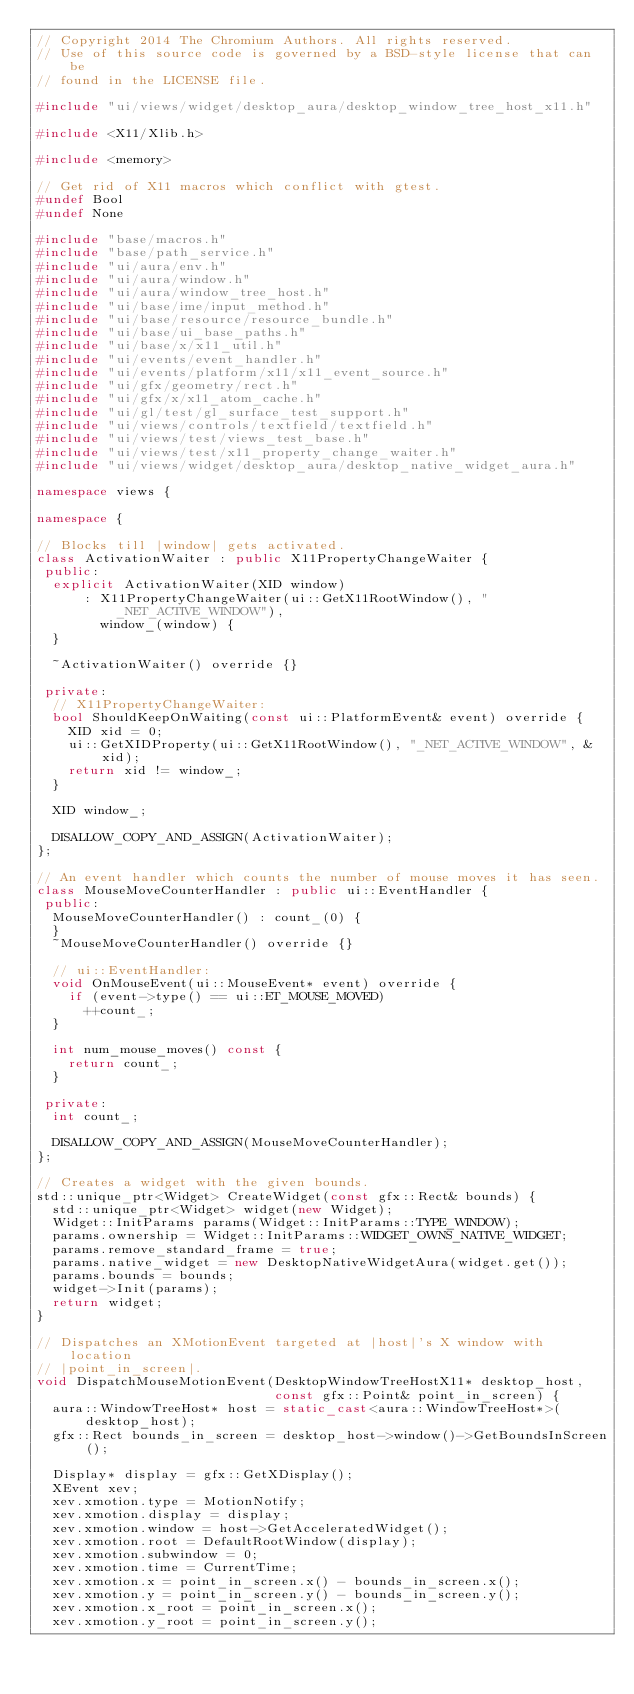Convert code to text. <code><loc_0><loc_0><loc_500><loc_500><_C++_>// Copyright 2014 The Chromium Authors. All rights reserved.
// Use of this source code is governed by a BSD-style license that can be
// found in the LICENSE file.

#include "ui/views/widget/desktop_aura/desktop_window_tree_host_x11.h"

#include <X11/Xlib.h>

#include <memory>

// Get rid of X11 macros which conflict with gtest.
#undef Bool
#undef None

#include "base/macros.h"
#include "base/path_service.h"
#include "ui/aura/env.h"
#include "ui/aura/window.h"
#include "ui/aura/window_tree_host.h"
#include "ui/base/ime/input_method.h"
#include "ui/base/resource/resource_bundle.h"
#include "ui/base/ui_base_paths.h"
#include "ui/base/x/x11_util.h"
#include "ui/events/event_handler.h"
#include "ui/events/platform/x11/x11_event_source.h"
#include "ui/gfx/geometry/rect.h"
#include "ui/gfx/x/x11_atom_cache.h"
#include "ui/gl/test/gl_surface_test_support.h"
#include "ui/views/controls/textfield/textfield.h"
#include "ui/views/test/views_test_base.h"
#include "ui/views/test/x11_property_change_waiter.h"
#include "ui/views/widget/desktop_aura/desktop_native_widget_aura.h"

namespace views {

namespace {

// Blocks till |window| gets activated.
class ActivationWaiter : public X11PropertyChangeWaiter {
 public:
  explicit ActivationWaiter(XID window)
      : X11PropertyChangeWaiter(ui::GetX11RootWindow(), "_NET_ACTIVE_WINDOW"),
        window_(window) {
  }

  ~ActivationWaiter() override {}

 private:
  // X11PropertyChangeWaiter:
  bool ShouldKeepOnWaiting(const ui::PlatformEvent& event) override {
    XID xid = 0;
    ui::GetXIDProperty(ui::GetX11RootWindow(), "_NET_ACTIVE_WINDOW", &xid);
    return xid != window_;
  }

  XID window_;

  DISALLOW_COPY_AND_ASSIGN(ActivationWaiter);
};

// An event handler which counts the number of mouse moves it has seen.
class MouseMoveCounterHandler : public ui::EventHandler {
 public:
  MouseMoveCounterHandler() : count_(0) {
  }
  ~MouseMoveCounterHandler() override {}

  // ui::EventHandler:
  void OnMouseEvent(ui::MouseEvent* event) override {
    if (event->type() == ui::ET_MOUSE_MOVED)
      ++count_;
  }

  int num_mouse_moves() const {
    return count_;
  }

 private:
  int count_;

  DISALLOW_COPY_AND_ASSIGN(MouseMoveCounterHandler);
};

// Creates a widget with the given bounds.
std::unique_ptr<Widget> CreateWidget(const gfx::Rect& bounds) {
  std::unique_ptr<Widget> widget(new Widget);
  Widget::InitParams params(Widget::InitParams::TYPE_WINDOW);
  params.ownership = Widget::InitParams::WIDGET_OWNS_NATIVE_WIDGET;
  params.remove_standard_frame = true;
  params.native_widget = new DesktopNativeWidgetAura(widget.get());
  params.bounds = bounds;
  widget->Init(params);
  return widget;
}

// Dispatches an XMotionEvent targeted at |host|'s X window with location
// |point_in_screen|.
void DispatchMouseMotionEvent(DesktopWindowTreeHostX11* desktop_host,
                              const gfx::Point& point_in_screen) {
  aura::WindowTreeHost* host = static_cast<aura::WindowTreeHost*>(desktop_host);
  gfx::Rect bounds_in_screen = desktop_host->window()->GetBoundsInScreen();

  Display* display = gfx::GetXDisplay();
  XEvent xev;
  xev.xmotion.type = MotionNotify;
  xev.xmotion.display = display;
  xev.xmotion.window = host->GetAcceleratedWidget();
  xev.xmotion.root = DefaultRootWindow(display);
  xev.xmotion.subwindow = 0;
  xev.xmotion.time = CurrentTime;
  xev.xmotion.x = point_in_screen.x() - bounds_in_screen.x();
  xev.xmotion.y = point_in_screen.y() - bounds_in_screen.y();
  xev.xmotion.x_root = point_in_screen.x();
  xev.xmotion.y_root = point_in_screen.y();</code> 